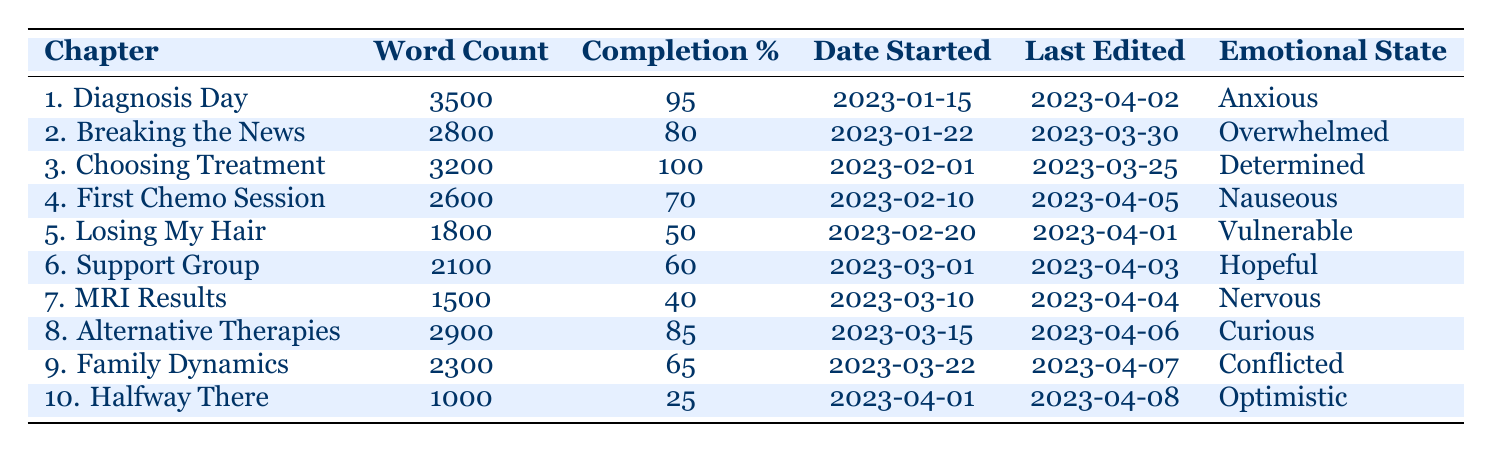What is the word count for Chapter 2? Chapter 2 is titled "Breaking the News." The corresponding word count from the table indicates that it has 2800 words.
Answer: 2800 Which chapter has the highest completion percentage? The chapter with the highest completion percentage is Chapter 3, titled "Choosing Treatment," which is completed at 100%.
Answer: Chapter 3 What is the average word count for chapters that have been completed at least 80%? The chapters that meet this criterion are Chapter 1 (3500), Chapter 2 (2800), and Chapter 3 (3200). The sum is 3500 + 2800 + 3200 = 9500. There are 3 chapters, so the average is 9500 / 3 = 3166.67.
Answer: 3166.67 Is Chapter 6 "Support Group" more complete than Chapter 5 "Losing My Hair"? Chapter 6 has a completion percentage of 60%, while Chapter 5 has a completion percentage of 50%. Therefore, Chapter 6 is more complete than Chapter 5.
Answer: Yes Which emotional state is associated with the chapter that has the lowest word count? The chapter with the lowest word count is Chapter 10 "Halfway There," which has 1000 words. Its associated emotional state is "Optimistic."
Answer: Optimistic How many chapters have a completion percentage of 70% or below? The chapters with a completion percentage of 70% or below are Chapter 4 (70%), Chapter 5 (50%), Chapter 6 (60%), and Chapter 7 (40%). Counting these gives a total of 4 chapters.
Answer: 4 What is the significance of the emotional states for completed chapters compared to those that are not completed? Completed chapters include a range of emotional states; however, examining Chapters 1 (95%), 2 (80%), and 3 (100%) shows states like "Anxious," "Overwhelmed," and "Determined," suggesting more positive emotions for higher completion percentages, while chapters with lower completion percentages tend to reflect more negative emotions. This suggests a correlation between completion and emotional states.
Answer: More positive emotions in completed chapters Identify the chapter with the earliest start date. Chapter 1 "Diagnosis Day" was started on 2023-01-15, making it the earliest among all chapters listed in the table.
Answer: Chapter 1 